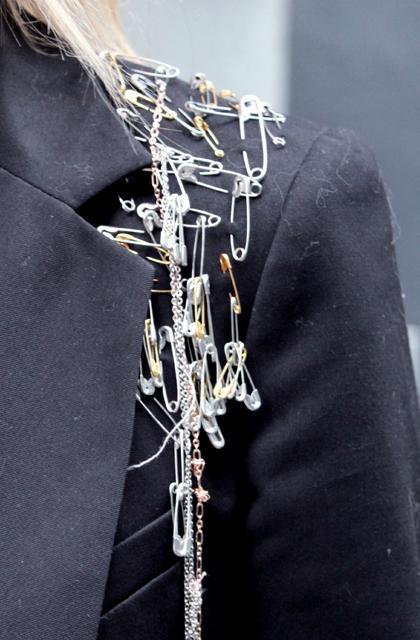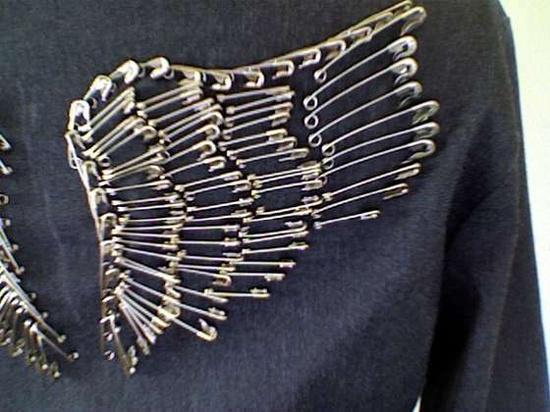The first image is the image on the left, the second image is the image on the right. Analyze the images presented: Is the assertion "One of the images shows high heeled platform shoes." valid? Answer yes or no. No. The first image is the image on the left, the second image is the image on the right. For the images displayed, is the sentence "someone is wearing a pair of pants full of safety pins and a pair of heels" factually correct? Answer yes or no. No. 